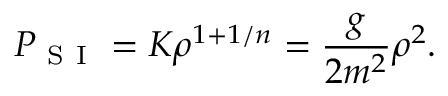<formula> <loc_0><loc_0><loc_500><loc_500>P _ { S I } = K \rho ^ { 1 + 1 / n } = \frac { g } { 2 m ^ { 2 } } \rho ^ { 2 } .</formula> 